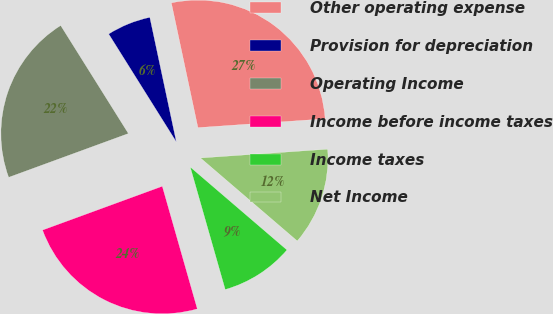<chart> <loc_0><loc_0><loc_500><loc_500><pie_chart><fcel>Other operating expense<fcel>Provision for depreciation<fcel>Operating Income<fcel>Income before income taxes<fcel>Income taxes<fcel>Net Income<nl><fcel>27.24%<fcel>5.57%<fcel>21.67%<fcel>23.84%<fcel>9.29%<fcel>12.38%<nl></chart> 